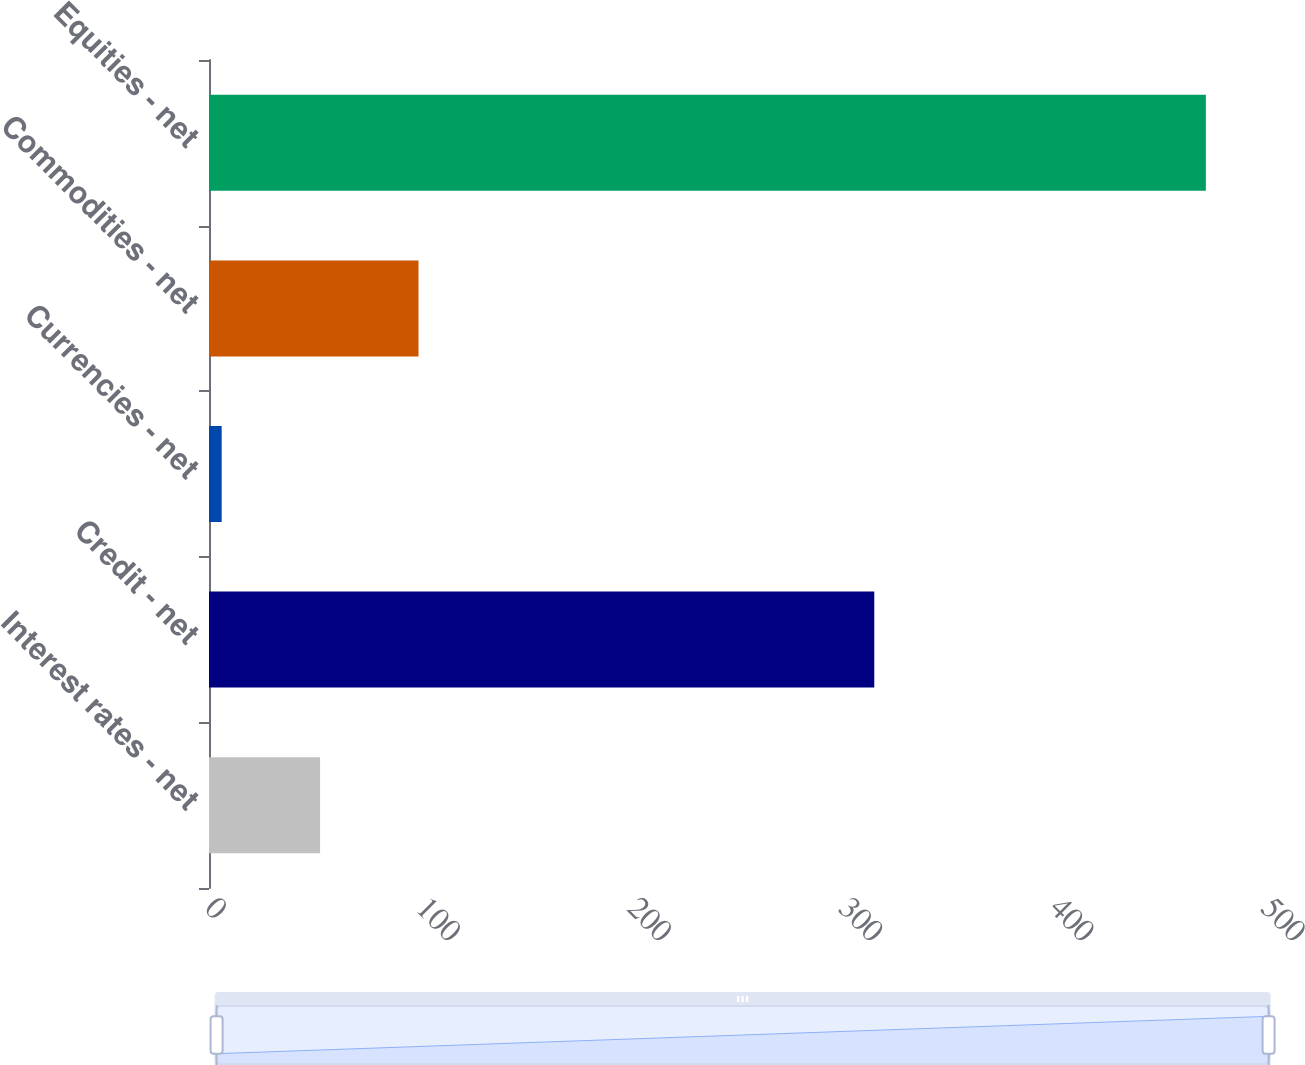<chart> <loc_0><loc_0><loc_500><loc_500><bar_chart><fcel>Interest rates - net<fcel>Credit - net<fcel>Currencies - net<fcel>Commodities - net<fcel>Equities - net<nl><fcel>52.6<fcel>315<fcel>6<fcel>99.2<fcel>472<nl></chart> 